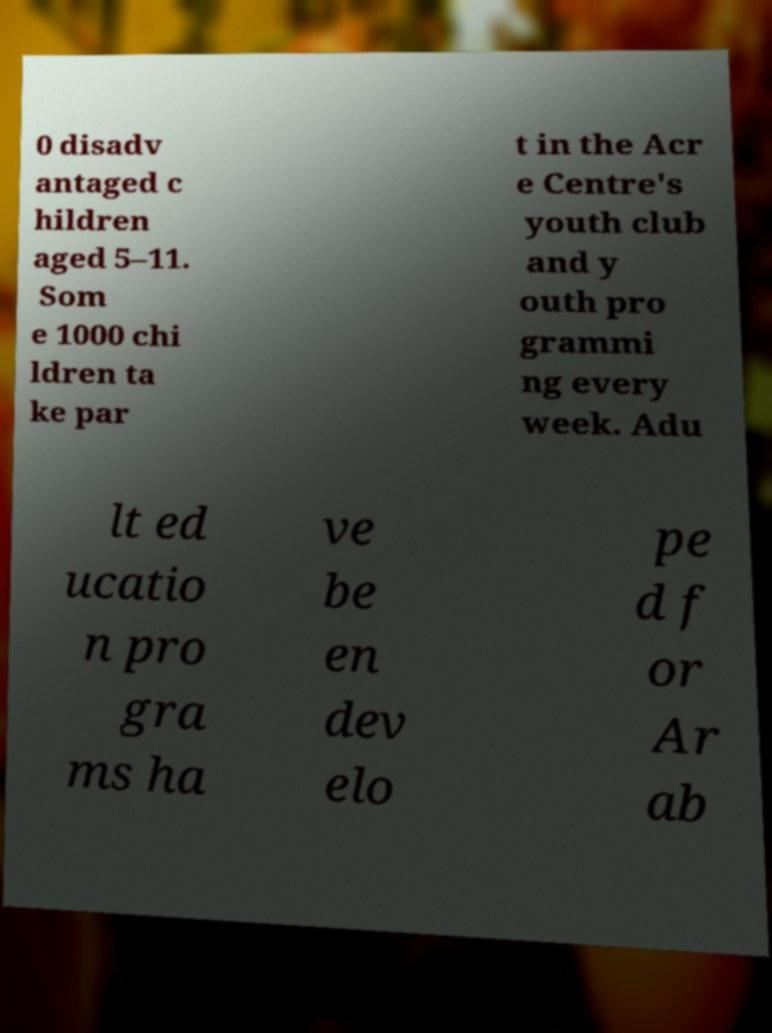Please read and relay the text visible in this image. What does it say? 0 disadv antaged c hildren aged 5–11. Som e 1000 chi ldren ta ke par t in the Acr e Centre's youth club and y outh pro grammi ng every week. Adu lt ed ucatio n pro gra ms ha ve be en dev elo pe d f or Ar ab 